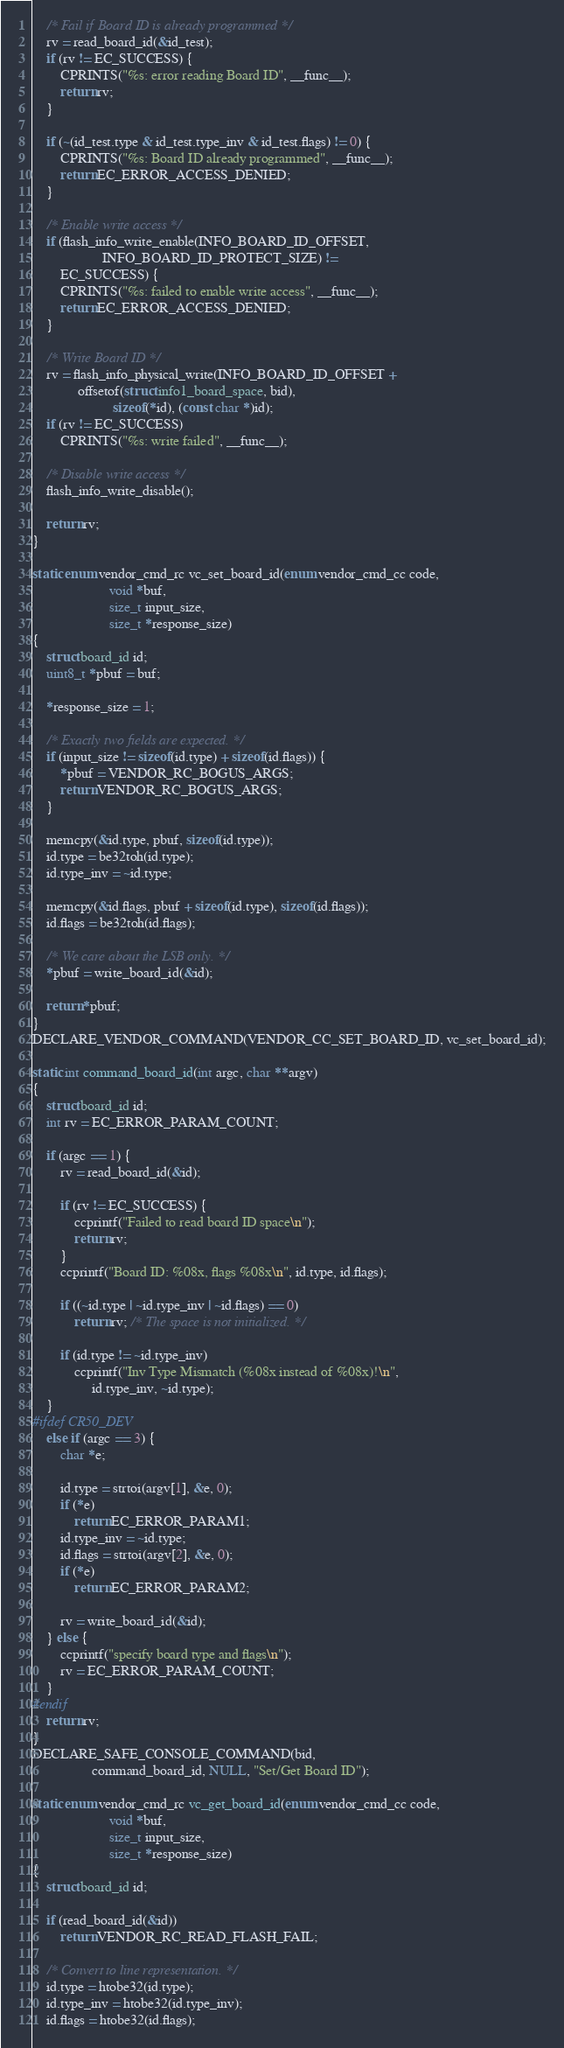Convert code to text. <code><loc_0><loc_0><loc_500><loc_500><_C_>
	/* Fail if Board ID is already programmed */
	rv = read_board_id(&id_test);
	if (rv != EC_SUCCESS) {
		CPRINTS("%s: error reading Board ID", __func__);
		return rv;
	}

	if (~(id_test.type & id_test.type_inv & id_test.flags) != 0) {
		CPRINTS("%s: Board ID already programmed", __func__);
		return EC_ERROR_ACCESS_DENIED;
	}

	/* Enable write access */
	if (flash_info_write_enable(INFO_BOARD_ID_OFFSET,
				    INFO_BOARD_ID_PROTECT_SIZE) !=
	    EC_SUCCESS) {
		CPRINTS("%s: failed to enable write access", __func__);
		return EC_ERROR_ACCESS_DENIED;
	}

	/* Write Board ID */
	rv = flash_info_physical_write(INFO_BOARD_ID_OFFSET +
			 offsetof(struct info1_board_space, bid),
				       sizeof(*id), (const char *)id);
	if (rv != EC_SUCCESS)
		CPRINTS("%s: write failed", __func__);

	/* Disable write access */
	flash_info_write_disable();

	return rv;
}

static enum vendor_cmd_rc vc_set_board_id(enum vendor_cmd_cc code,
					  void *buf,
					  size_t input_size,
					  size_t *response_size)
{
	struct board_id id;
	uint8_t *pbuf = buf;

	*response_size = 1;

	/* Exactly two fields are expected. */
	if (input_size != sizeof(id.type) + sizeof(id.flags)) {
		*pbuf = VENDOR_RC_BOGUS_ARGS;
		return VENDOR_RC_BOGUS_ARGS;
	}

	memcpy(&id.type, pbuf, sizeof(id.type));
	id.type = be32toh(id.type);
	id.type_inv = ~id.type;

	memcpy(&id.flags, pbuf + sizeof(id.type), sizeof(id.flags));
	id.flags = be32toh(id.flags);

	/* We care about the LSB only. */
	*pbuf = write_board_id(&id);

	return *pbuf;
}
DECLARE_VENDOR_COMMAND(VENDOR_CC_SET_BOARD_ID, vc_set_board_id);

static int command_board_id(int argc, char **argv)
{
	struct board_id id;
	int rv = EC_ERROR_PARAM_COUNT;

	if (argc == 1) {
		rv = read_board_id(&id);

		if (rv != EC_SUCCESS) {
			ccprintf("Failed to read board ID space\n");
			return rv;
		}
		ccprintf("Board ID: %08x, flags %08x\n", id.type, id.flags);

		if ((~id.type | ~id.type_inv | ~id.flags) == 0)
			return rv; /* The space is not initialized. */

		if (id.type != ~id.type_inv)
			ccprintf("Inv Type Mismatch (%08x instead of %08x)!\n",
				 id.type_inv, ~id.type);
	}
#ifdef CR50_DEV
	else if (argc == 3) {
		char *e;

		id.type = strtoi(argv[1], &e, 0);
		if (*e)
			return EC_ERROR_PARAM1;
		id.type_inv = ~id.type;
		id.flags = strtoi(argv[2], &e, 0);
		if (*e)
			return EC_ERROR_PARAM2;

		rv = write_board_id(&id);
	} else {
		ccprintf("specify board type and flags\n");
		rv = EC_ERROR_PARAM_COUNT;
	}
#endif
	return rv;
}
DECLARE_SAFE_CONSOLE_COMMAND(bid,
			     command_board_id, NULL, "Set/Get Board ID");

static enum vendor_cmd_rc vc_get_board_id(enum vendor_cmd_cc code,
					  void *buf,
					  size_t input_size,
					  size_t *response_size)
{
	struct board_id id;

	if (read_board_id(&id))
		return VENDOR_RC_READ_FLASH_FAIL;

	/* Convert to line representation. */
	id.type = htobe32(id.type);
	id.type_inv = htobe32(id.type_inv);
	id.flags = htobe32(id.flags);
</code> 